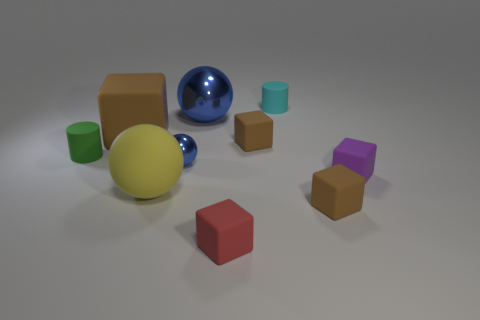Subtract all purple cylinders. How many brown blocks are left? 3 Subtract all purple cubes. How many cubes are left? 4 Subtract all green cubes. Subtract all blue cylinders. How many cubes are left? 5 Subtract all cylinders. How many objects are left? 8 Subtract all green balls. Subtract all small purple matte blocks. How many objects are left? 9 Add 2 small rubber cylinders. How many small rubber cylinders are left? 4 Add 3 yellow things. How many yellow things exist? 4 Subtract 2 brown cubes. How many objects are left? 8 